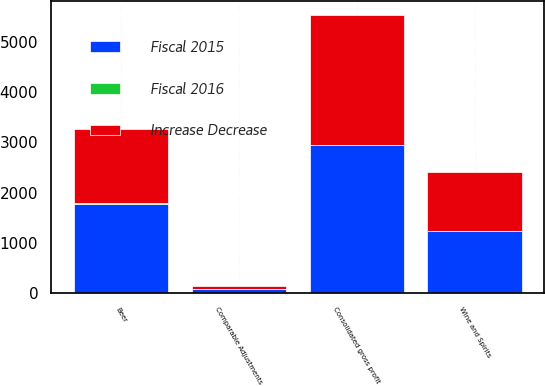<chart> <loc_0><loc_0><loc_500><loc_500><stacked_bar_chart><ecel><fcel>Beer<fcel>Wine and Spirits<fcel>Comparable Adjustments<fcel>Consolidated gross profit<nl><fcel>Fiscal 2015<fcel>1776<fcel>1235<fcel>68.7<fcel>2942.3<nl><fcel>Increase Decrease<fcel>1465.8<fcel>1172.3<fcel>59.5<fcel>2578.6<nl><fcel>Fiscal 2016<fcel>21<fcel>5<fcel>15<fcel>14<nl></chart> 